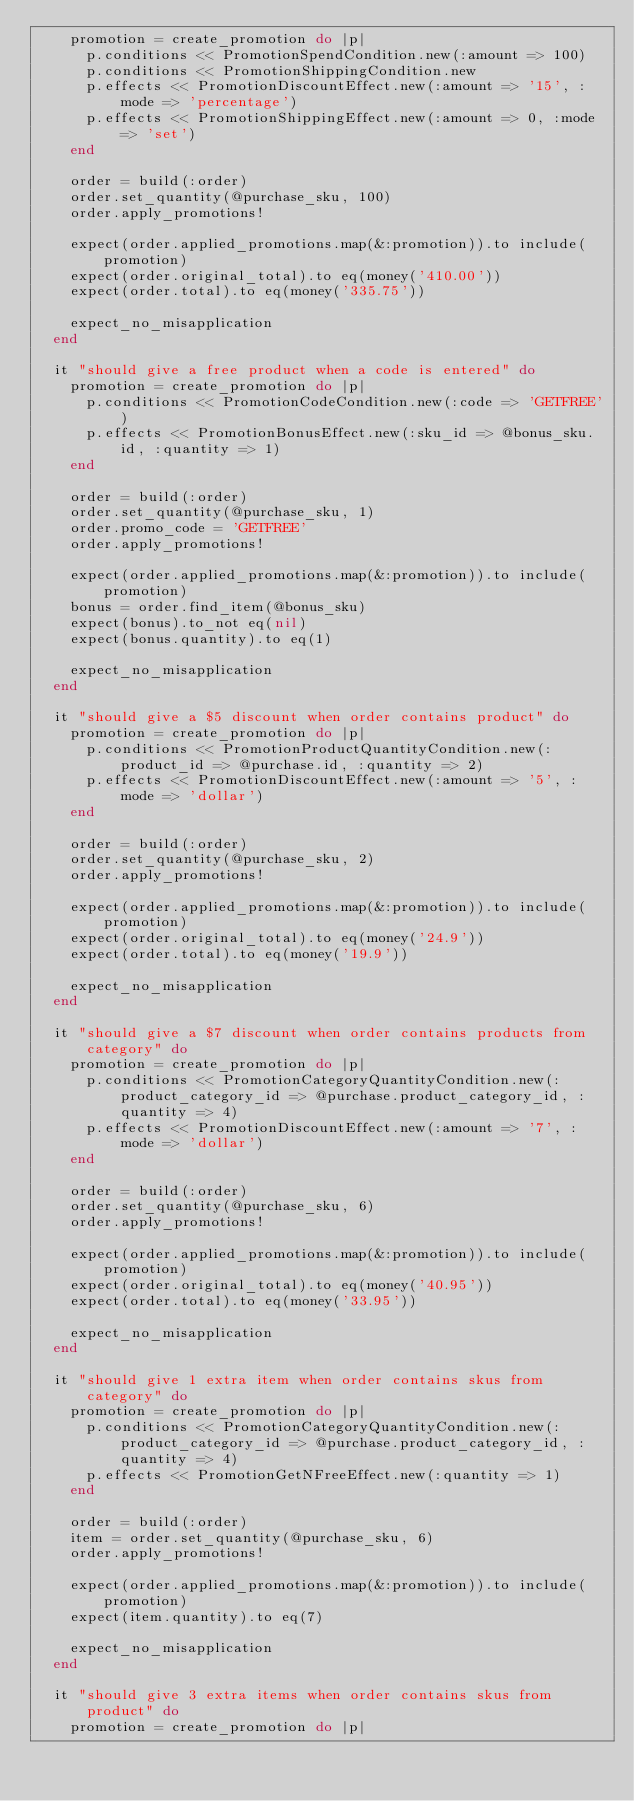<code> <loc_0><loc_0><loc_500><loc_500><_Ruby_>    promotion = create_promotion do |p|
      p.conditions << PromotionSpendCondition.new(:amount => 100)
      p.conditions << PromotionShippingCondition.new
      p.effects << PromotionDiscountEffect.new(:amount => '15', :mode => 'percentage')
      p.effects << PromotionShippingEffect.new(:amount => 0, :mode => 'set')
    end

    order = build(:order)
    order.set_quantity(@purchase_sku, 100)
    order.apply_promotions!

    expect(order.applied_promotions.map(&:promotion)).to include(promotion)
    expect(order.original_total).to eq(money('410.00'))
    expect(order.total).to eq(money('335.75'))

    expect_no_misapplication
  end

  it "should give a free product when a code is entered" do
    promotion = create_promotion do |p|
      p.conditions << PromotionCodeCondition.new(:code => 'GETFREE')
      p.effects << PromotionBonusEffect.new(:sku_id => @bonus_sku.id, :quantity => 1)
    end

    order = build(:order)
    order.set_quantity(@purchase_sku, 1)
    order.promo_code = 'GETFREE'
    order.apply_promotions!

    expect(order.applied_promotions.map(&:promotion)).to include(promotion)
    bonus = order.find_item(@bonus_sku)
    expect(bonus).to_not eq(nil)
    expect(bonus.quantity).to eq(1)

    expect_no_misapplication
  end

  it "should give a $5 discount when order contains product" do
    promotion = create_promotion do |p|
      p.conditions << PromotionProductQuantityCondition.new(:product_id => @purchase.id, :quantity => 2)
      p.effects << PromotionDiscountEffect.new(:amount => '5', :mode => 'dollar')
    end

    order = build(:order)
    order.set_quantity(@purchase_sku, 2)
    order.apply_promotions!

    expect(order.applied_promotions.map(&:promotion)).to include(promotion)
    expect(order.original_total).to eq(money('24.9'))
    expect(order.total).to eq(money('19.9'))

    expect_no_misapplication
  end

  it "should give a $7 discount when order contains products from category" do
    promotion = create_promotion do |p|
      p.conditions << PromotionCategoryQuantityCondition.new(:product_category_id => @purchase.product_category_id, :quantity => 4)
      p.effects << PromotionDiscountEffect.new(:amount => '7', :mode => 'dollar')
    end

    order = build(:order)
    order.set_quantity(@purchase_sku, 6)
    order.apply_promotions!

    expect(order.applied_promotions.map(&:promotion)).to include(promotion)
    expect(order.original_total).to eq(money('40.95'))
    expect(order.total).to eq(money('33.95'))

    expect_no_misapplication
  end

  it "should give 1 extra item when order contains skus from category" do
    promotion = create_promotion do |p|
      p.conditions << PromotionCategoryQuantityCondition.new(:product_category_id => @purchase.product_category_id, :quantity => 4)
      p.effects << PromotionGetNFreeEffect.new(:quantity => 1)
    end

    order = build(:order)
    item = order.set_quantity(@purchase_sku, 6)
    order.apply_promotions!

    expect(order.applied_promotions.map(&:promotion)).to include(promotion)
    expect(item.quantity).to eq(7)

    expect_no_misapplication
  end

  it "should give 3 extra items when order contains skus from product" do
    promotion = create_promotion do |p|</code> 